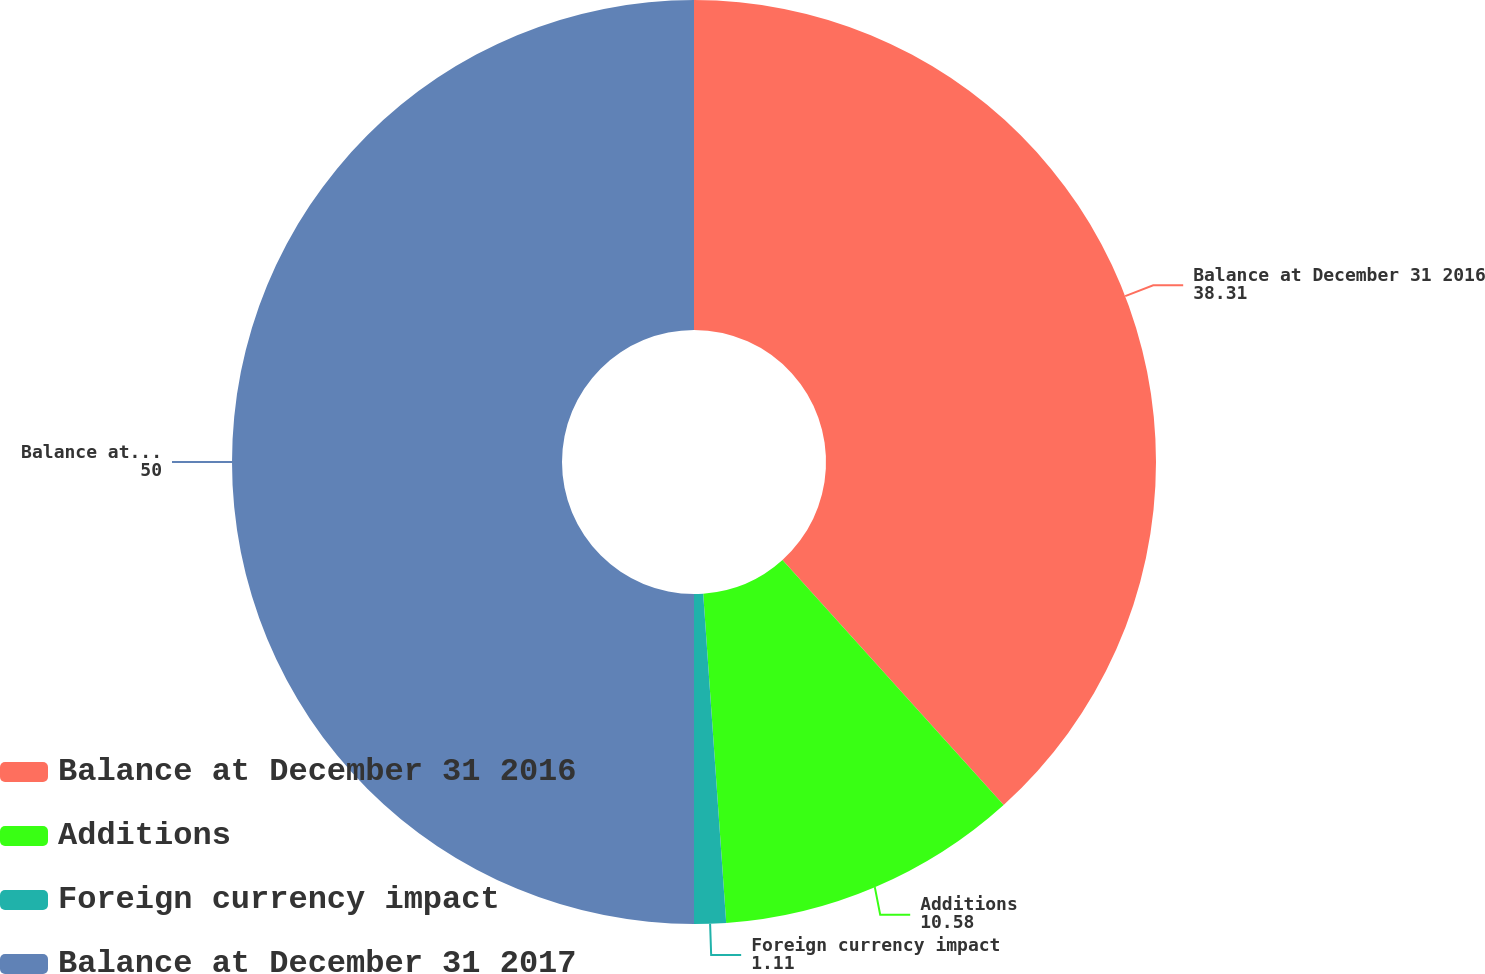<chart> <loc_0><loc_0><loc_500><loc_500><pie_chart><fcel>Balance at December 31 2016<fcel>Additions<fcel>Foreign currency impact<fcel>Balance at December 31 2017<nl><fcel>38.31%<fcel>10.58%<fcel>1.11%<fcel>50.0%<nl></chart> 